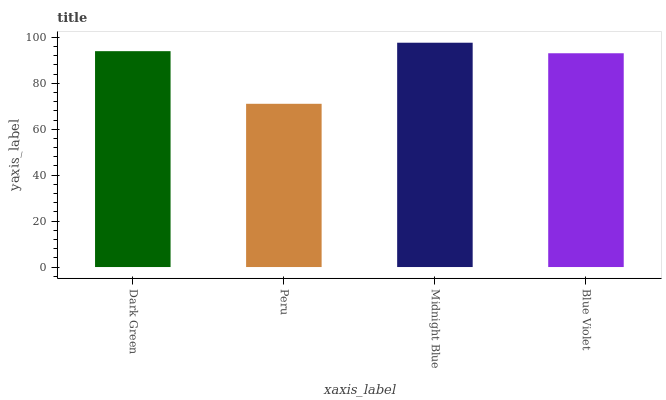Is Peru the minimum?
Answer yes or no. Yes. Is Midnight Blue the maximum?
Answer yes or no. Yes. Is Midnight Blue the minimum?
Answer yes or no. No. Is Peru the maximum?
Answer yes or no. No. Is Midnight Blue greater than Peru?
Answer yes or no. Yes. Is Peru less than Midnight Blue?
Answer yes or no. Yes. Is Peru greater than Midnight Blue?
Answer yes or no. No. Is Midnight Blue less than Peru?
Answer yes or no. No. Is Dark Green the high median?
Answer yes or no. Yes. Is Blue Violet the low median?
Answer yes or no. Yes. Is Midnight Blue the high median?
Answer yes or no. No. Is Midnight Blue the low median?
Answer yes or no. No. 